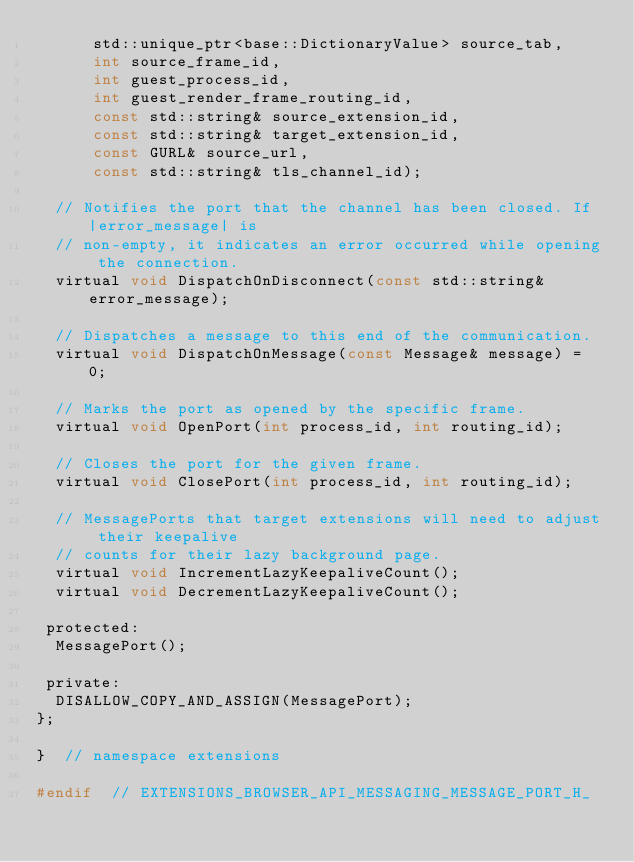<code> <loc_0><loc_0><loc_500><loc_500><_C_>      std::unique_ptr<base::DictionaryValue> source_tab,
      int source_frame_id,
      int guest_process_id,
      int guest_render_frame_routing_id,
      const std::string& source_extension_id,
      const std::string& target_extension_id,
      const GURL& source_url,
      const std::string& tls_channel_id);

  // Notifies the port that the channel has been closed. If |error_message| is
  // non-empty, it indicates an error occurred while opening the connection.
  virtual void DispatchOnDisconnect(const std::string& error_message);

  // Dispatches a message to this end of the communication.
  virtual void DispatchOnMessage(const Message& message) = 0;

  // Marks the port as opened by the specific frame.
  virtual void OpenPort(int process_id, int routing_id);

  // Closes the port for the given frame.
  virtual void ClosePort(int process_id, int routing_id);

  // MessagePorts that target extensions will need to adjust their keepalive
  // counts for their lazy background page.
  virtual void IncrementLazyKeepaliveCount();
  virtual void DecrementLazyKeepaliveCount();

 protected:
  MessagePort();

 private:
  DISALLOW_COPY_AND_ASSIGN(MessagePort);
};

}  // namespace extensions

#endif  // EXTENSIONS_BROWSER_API_MESSAGING_MESSAGE_PORT_H_
</code> 